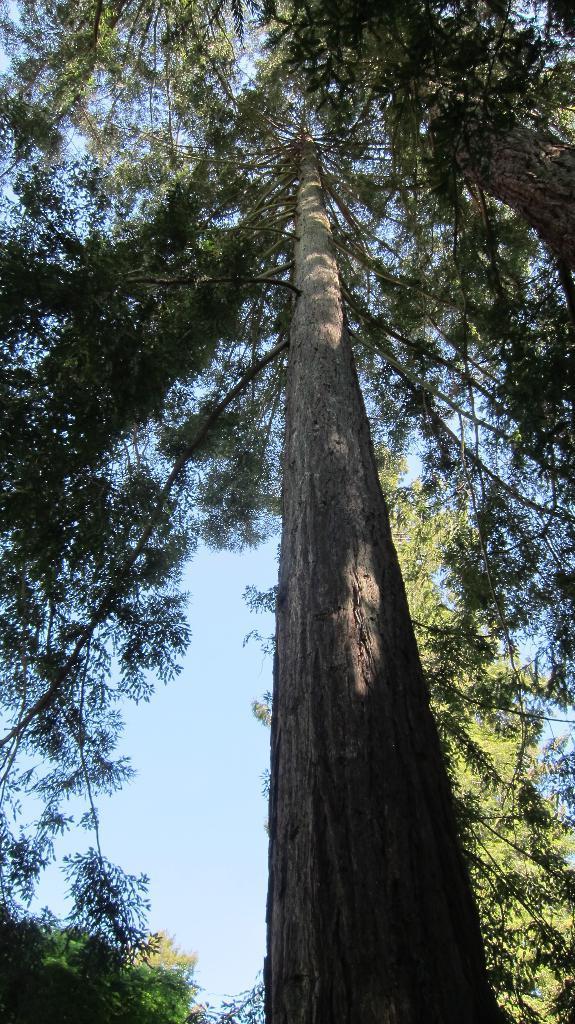Can you describe this image briefly? In this image we can see trees. In the background, we can see the sky. 